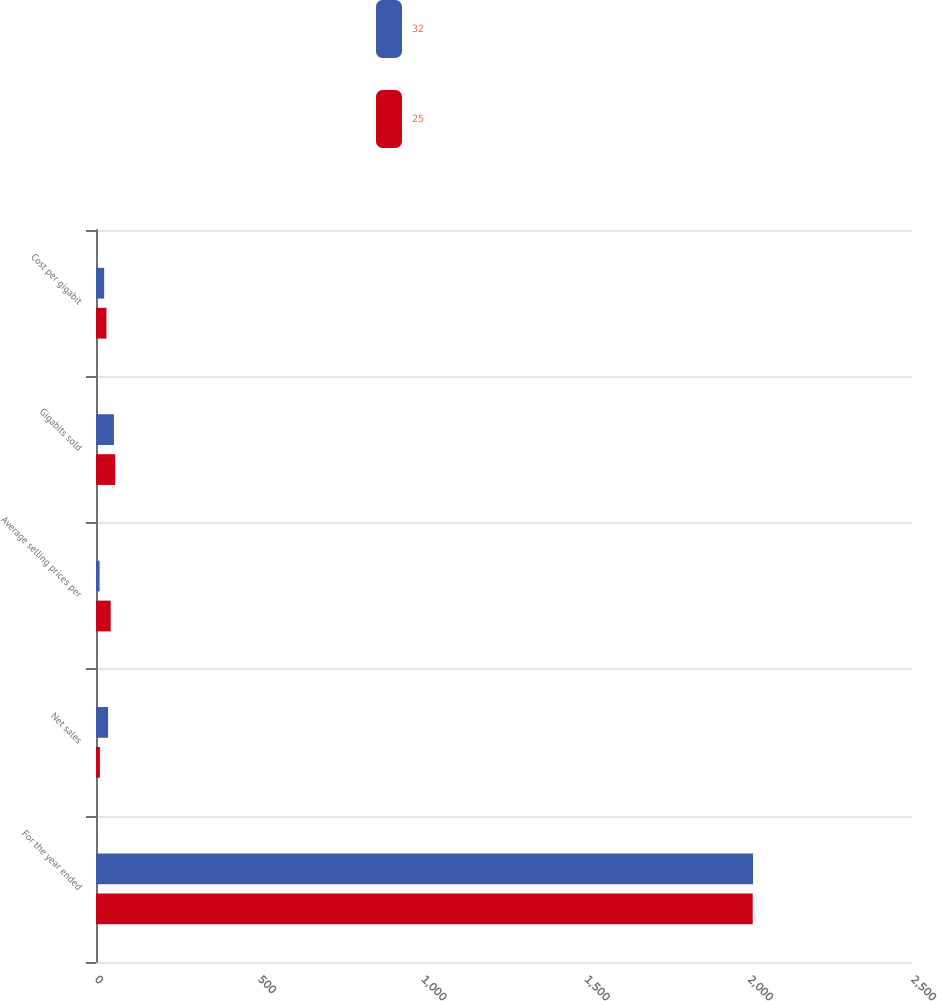Convert chart to OTSL. <chart><loc_0><loc_0><loc_500><loc_500><stacked_bar_chart><ecel><fcel>For the year ended<fcel>Net sales<fcel>Average selling prices per<fcel>Gigabits sold<fcel>Cost per gigabit<nl><fcel>32<fcel>2013<fcel>37<fcel>11<fcel>55<fcel>25<nl><fcel>25<fcel>2012<fcel>12<fcel>45<fcel>59<fcel>32<nl></chart> 